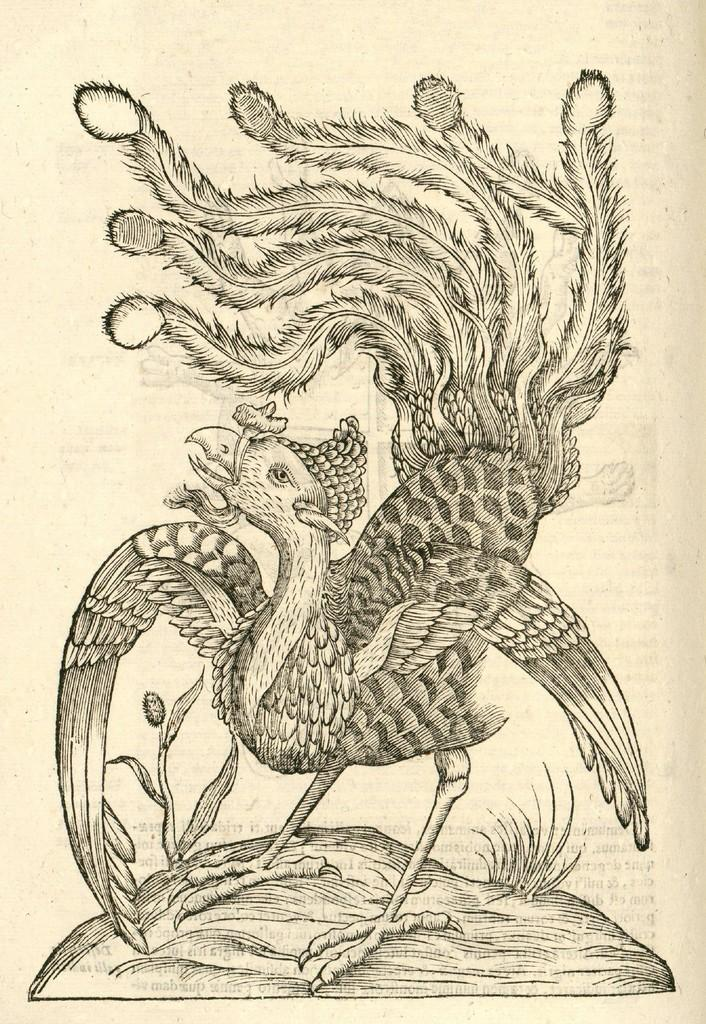What is the main subject of the sketch in the image? The main subject of the sketch in the image is a bird. Where is the bird located in the sketch? The bird is standing on a rock in the sketch. What type of vegetation is present on the rock in the sketch? There is grass on the rock in the sketch. What is the color of the paper on which the sketch is drawn? The sketch is on cream-colored paper. What type of sponge is being used to clean the bird in the image? There is no sponge or cleaning activity depicted in the image; it is a sketch of a bird standing on a rock with grass. 